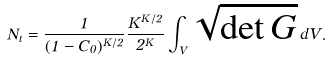<formula> <loc_0><loc_0><loc_500><loc_500>N _ { t } = \frac { 1 } { ( 1 - C _ { 0 } ) ^ { K / 2 } } \frac { K ^ { K / 2 } } { 2 ^ { K } } \int _ { V } \sqrt { \det G } \, d V .</formula> 